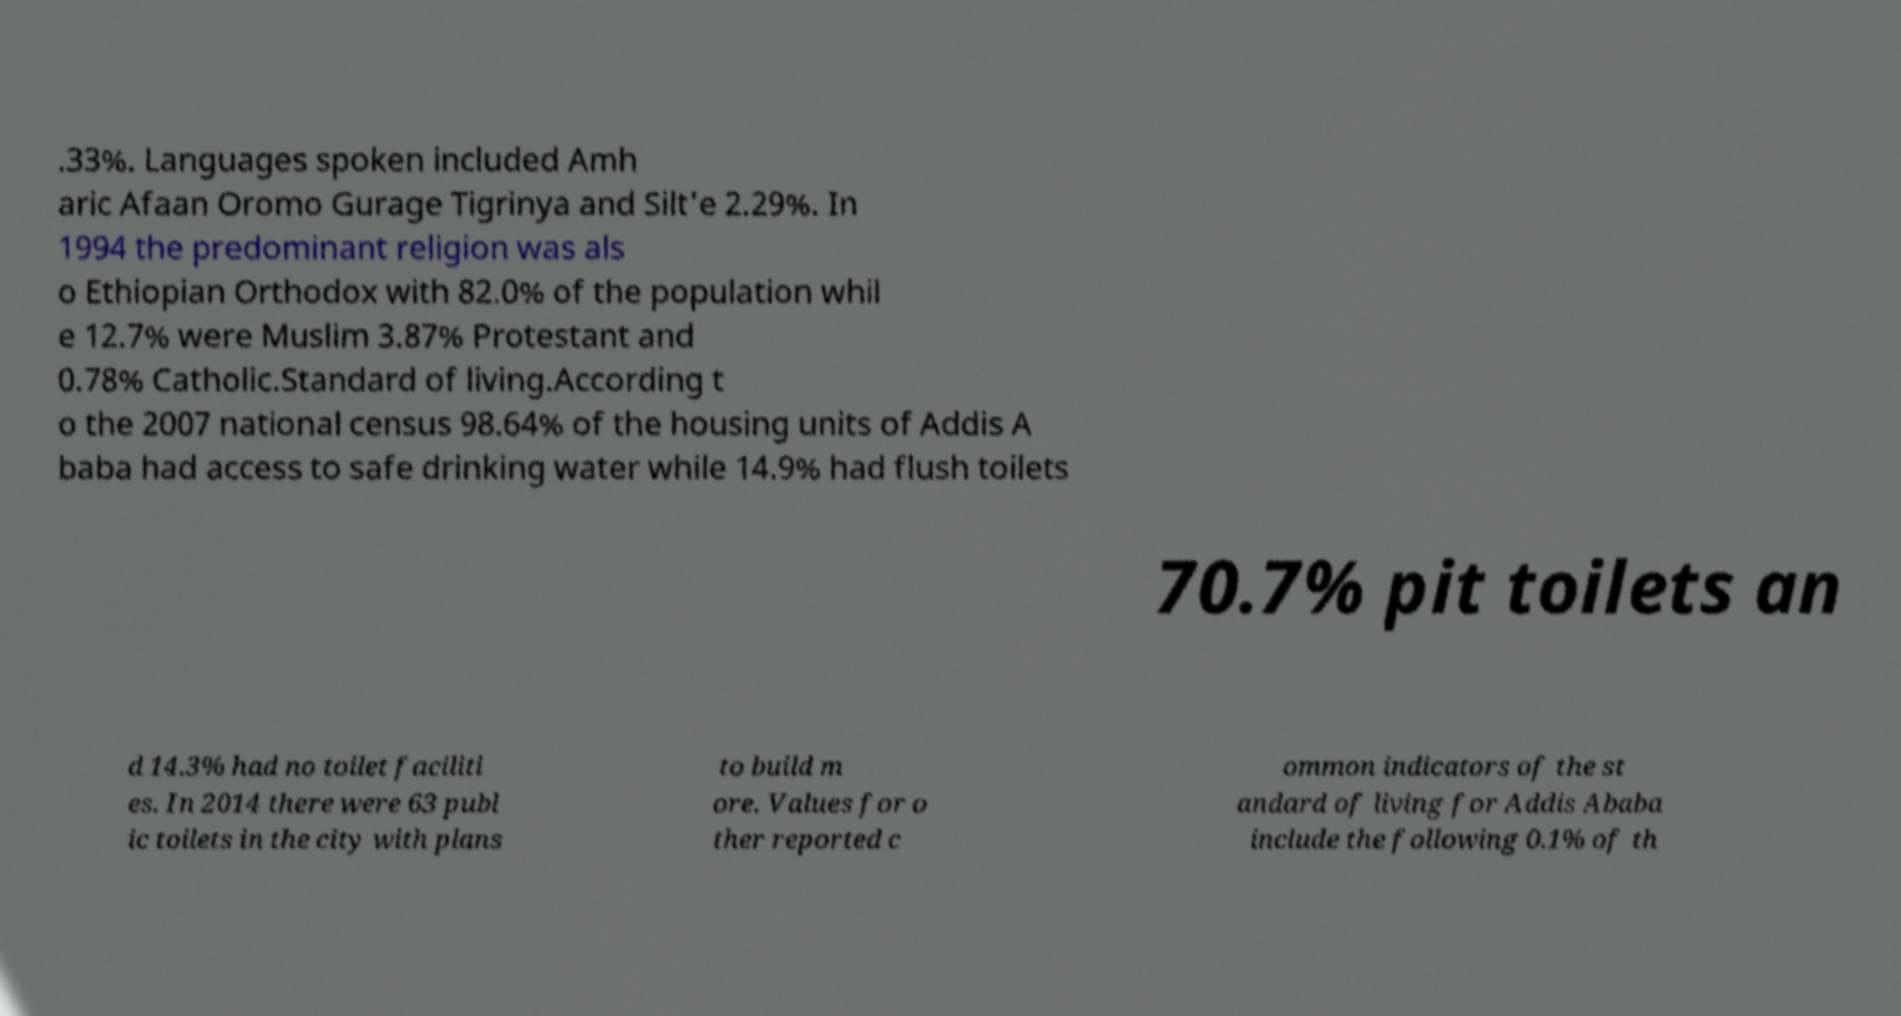Can you accurately transcribe the text from the provided image for me? .33%. Languages spoken included Amh aric Afaan Oromo Gurage Tigrinya and Silt'e 2.29%. In 1994 the predominant religion was als o Ethiopian Orthodox with 82.0% of the population whil e 12.7% were Muslim 3.87% Protestant and 0.78% Catholic.Standard of living.According t o the 2007 national census 98.64% of the housing units of Addis A baba had access to safe drinking water while 14.9% had flush toilets 70.7% pit toilets an d 14.3% had no toilet faciliti es. In 2014 there were 63 publ ic toilets in the city with plans to build m ore. Values for o ther reported c ommon indicators of the st andard of living for Addis Ababa include the following 0.1% of th 